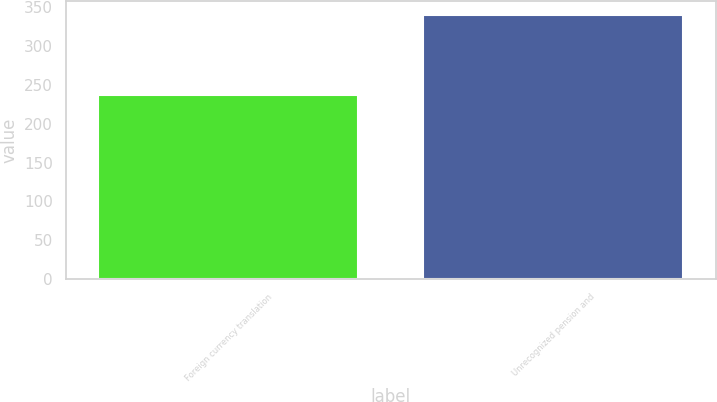Convert chart to OTSL. <chart><loc_0><loc_0><loc_500><loc_500><bar_chart><fcel>Foreign currency translation<fcel>Unrecognized pension and<nl><fcel>237.5<fcel>340.6<nl></chart> 